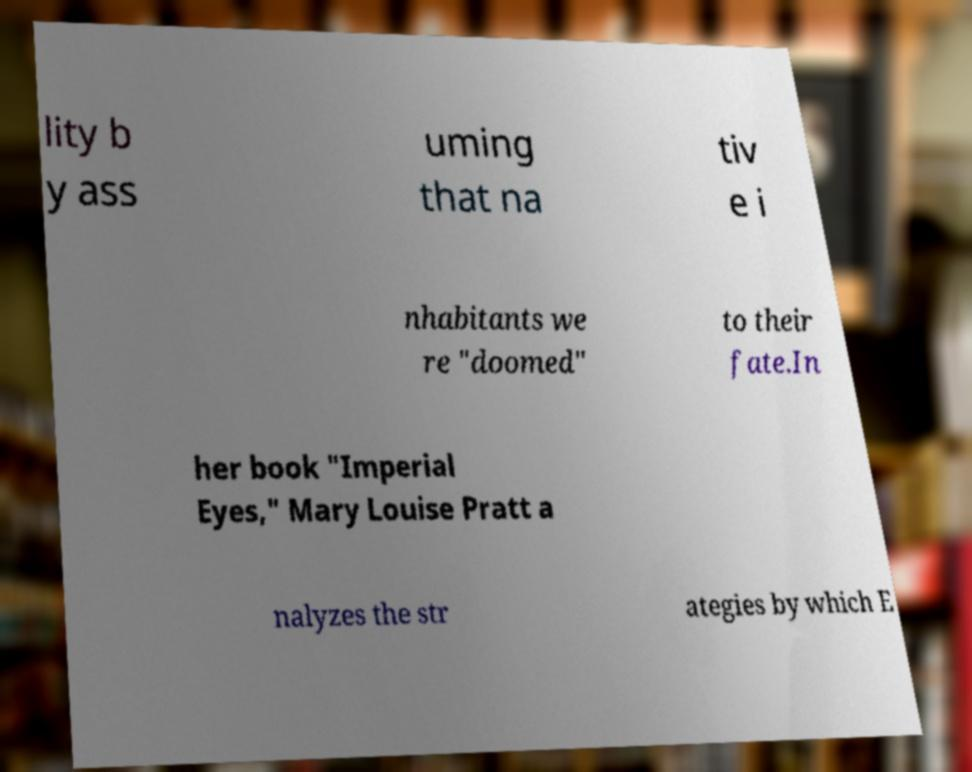There's text embedded in this image that I need extracted. Can you transcribe it verbatim? lity b y ass uming that na tiv e i nhabitants we re "doomed" to their fate.In her book "Imperial Eyes," Mary Louise Pratt a nalyzes the str ategies by which E 